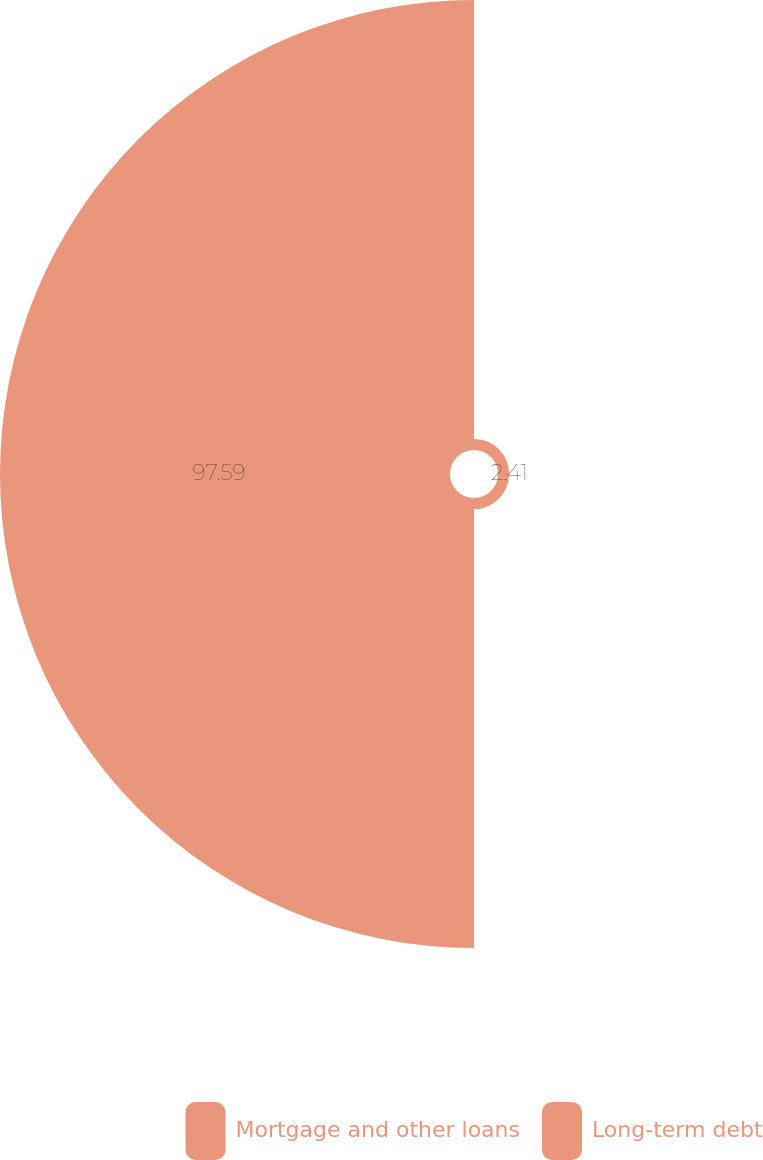Convert chart. <chart><loc_0><loc_0><loc_500><loc_500><pie_chart><fcel>Mortgage and other loans<fcel>Long-term debt<nl><fcel>2.41%<fcel>97.59%<nl></chart> 